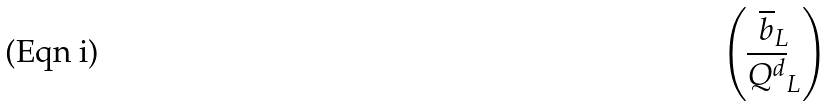Convert formula to latex. <formula><loc_0><loc_0><loc_500><loc_500>\begin{pmatrix} \overline { b } _ { L } \\ \overline { Q ^ { d } } _ { L } \end{pmatrix}</formula> 